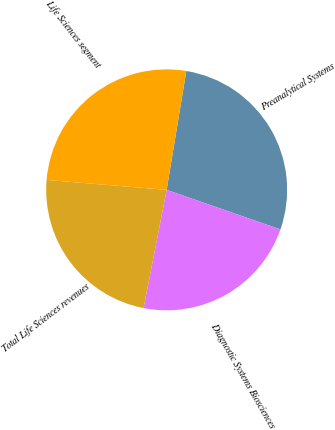Convert chart. <chart><loc_0><loc_0><loc_500><loc_500><pie_chart><fcel>Preanalytical Systems<fcel>Diagnostic Systems Biosciences<fcel>Total Life Sciences revenues<fcel>Life Sciences segment<nl><fcel>27.72%<fcel>22.74%<fcel>23.24%<fcel>26.3%<nl></chart> 